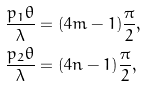Convert formula to latex. <formula><loc_0><loc_0><loc_500><loc_500>\frac { p _ { 1 } \theta } { \lambda } & = ( 4 m - 1 ) \frac { \pi } { 2 } , \\ \frac { p _ { 2 } \theta } { \lambda } & = ( 4 n - 1 ) \frac { \pi } { 2 } ,</formula> 